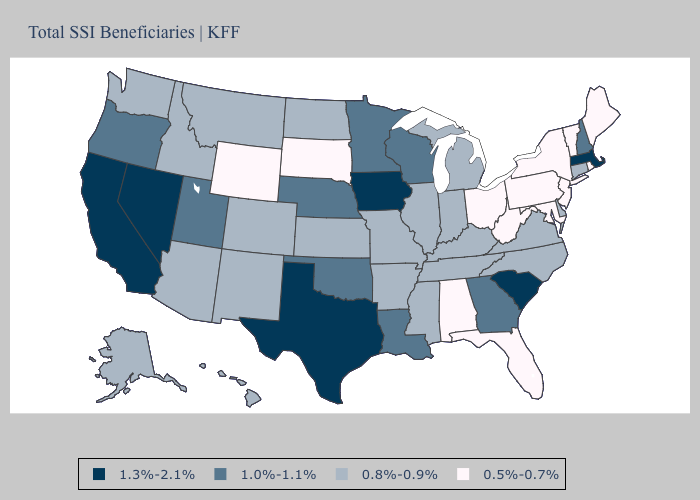What is the value of Alabama?
Short answer required. 0.5%-0.7%. Among the states that border New Hampshire , which have the highest value?
Quick response, please. Massachusetts. Name the states that have a value in the range 0.5%-0.7%?
Give a very brief answer. Alabama, Florida, Maine, Maryland, New Jersey, New York, Ohio, Pennsylvania, Rhode Island, South Dakota, Vermont, West Virginia, Wyoming. Does New Hampshire have the lowest value in the Northeast?
Answer briefly. No. Name the states that have a value in the range 0.8%-0.9%?
Answer briefly. Alaska, Arizona, Arkansas, Colorado, Connecticut, Delaware, Hawaii, Idaho, Illinois, Indiana, Kansas, Kentucky, Michigan, Mississippi, Missouri, Montana, New Mexico, North Carolina, North Dakota, Tennessee, Virginia, Washington. What is the highest value in states that border Montana?
Concise answer only. 0.8%-0.9%. Does the map have missing data?
Quick response, please. No. What is the value of Florida?
Give a very brief answer. 0.5%-0.7%. How many symbols are there in the legend?
Keep it brief. 4. What is the value of Michigan?
Be succinct. 0.8%-0.9%. Does the map have missing data?
Short answer required. No. Which states have the highest value in the USA?
Quick response, please. California, Iowa, Massachusetts, Nevada, South Carolina, Texas. What is the lowest value in the Northeast?
Give a very brief answer. 0.5%-0.7%. Name the states that have a value in the range 0.8%-0.9%?
Short answer required. Alaska, Arizona, Arkansas, Colorado, Connecticut, Delaware, Hawaii, Idaho, Illinois, Indiana, Kansas, Kentucky, Michigan, Mississippi, Missouri, Montana, New Mexico, North Carolina, North Dakota, Tennessee, Virginia, Washington. Name the states that have a value in the range 1.3%-2.1%?
Answer briefly. California, Iowa, Massachusetts, Nevada, South Carolina, Texas. 